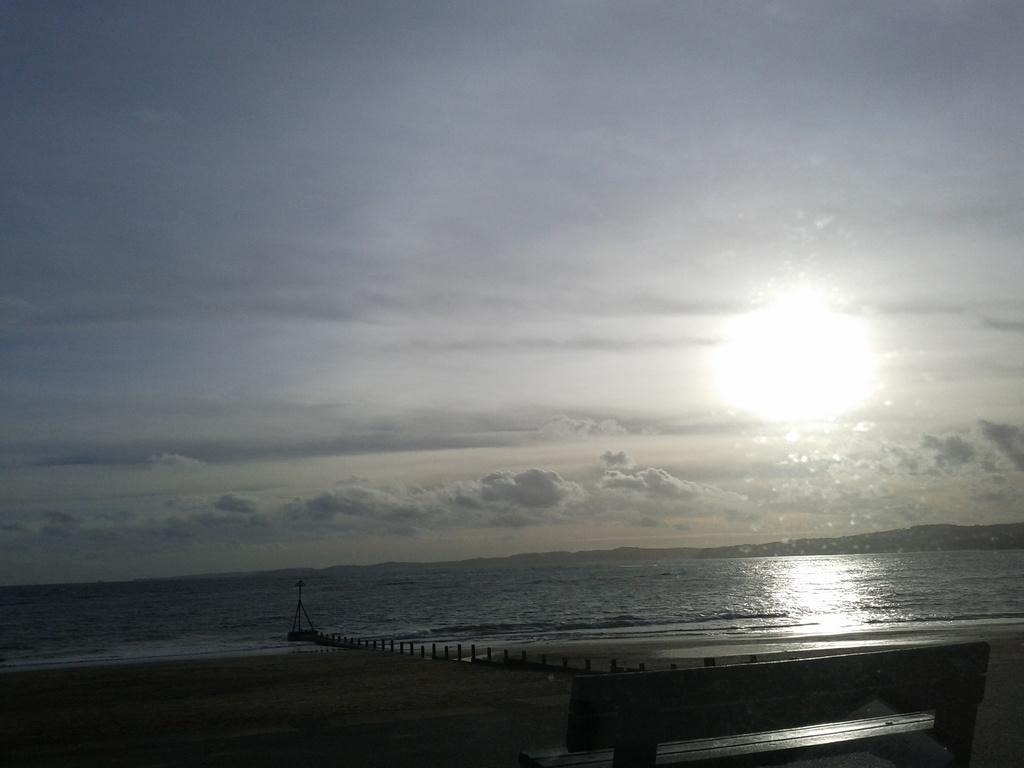How would you summarize this image in a sentence or two? This is the picture of a sea. In the foreground there is a bench. At the back there is a pole and there is water. At the top there is sky and there are clouds and there is a sun. At the bottom there is sand. 